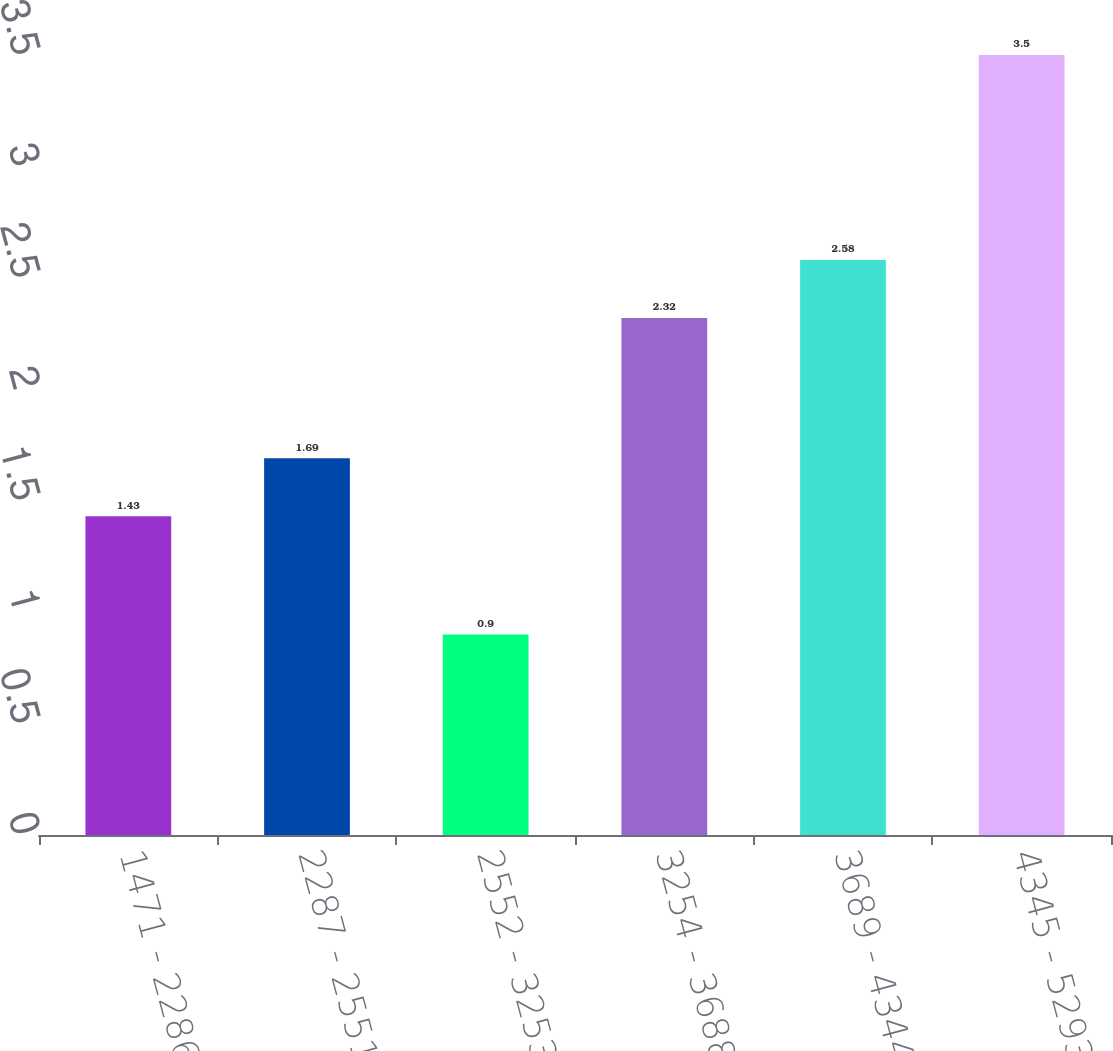<chart> <loc_0><loc_0><loc_500><loc_500><bar_chart><fcel>1471 - 2286<fcel>2287 - 2551<fcel>2552 - 3253<fcel>3254 - 3688<fcel>3689 - 4344<fcel>4345 - 5293<nl><fcel>1.43<fcel>1.69<fcel>0.9<fcel>2.32<fcel>2.58<fcel>3.5<nl></chart> 